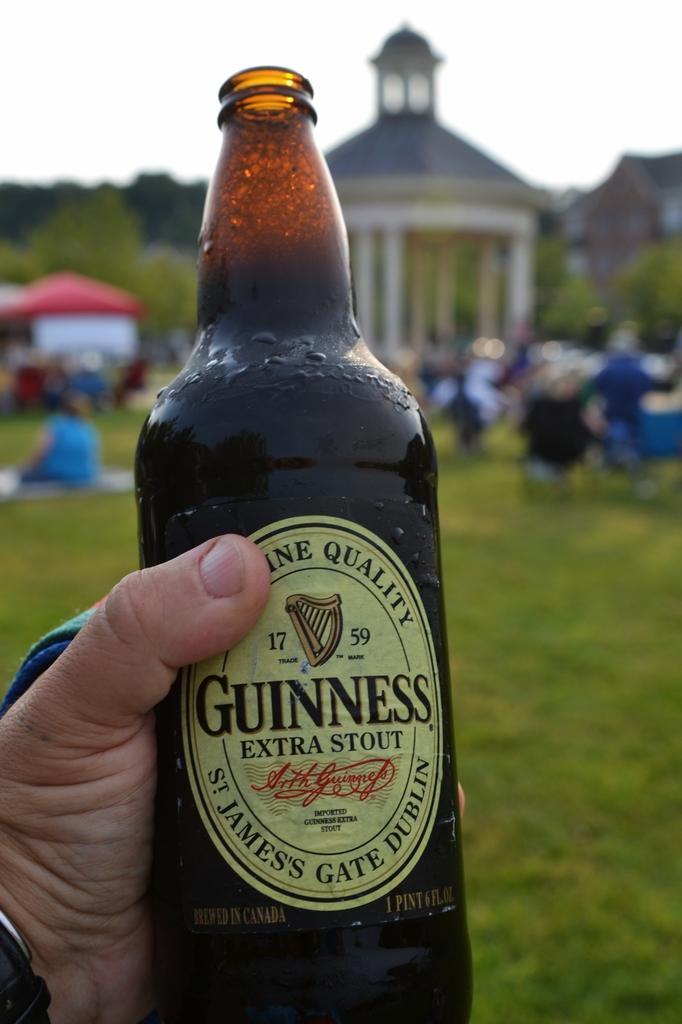Describe this image in one or two sentences. In this picture we can see bottle with drink in it where it is hold by some persons hand and in background we can see house, some persons, trees, sky, grass and it is blur. 